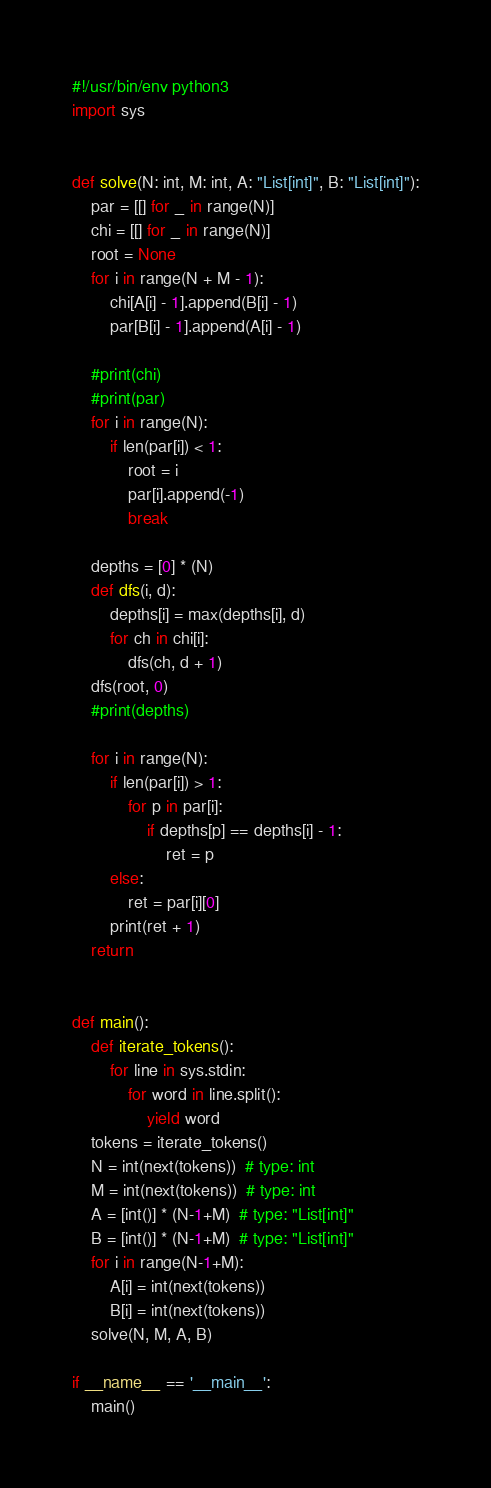<code> <loc_0><loc_0><loc_500><loc_500><_Python_>#!/usr/bin/env python3
import sys


def solve(N: int, M: int, A: "List[int]", B: "List[int]"):
    par = [[] for _ in range(N)]
    chi = [[] for _ in range(N)]
    root = None
    for i in range(N + M - 1):
        chi[A[i] - 1].append(B[i] - 1)
        par[B[i] - 1].append(A[i] - 1)

    #print(chi)
    #print(par)
    for i in range(N):
        if len(par[i]) < 1:
            root = i
            par[i].append(-1)
            break

    depths = [0] * (N)
    def dfs(i, d):
        depths[i] = max(depths[i], d)
        for ch in chi[i]:
            dfs(ch, d + 1)
    dfs(root, 0)
    #print(depths)

    for i in range(N):
        if len(par[i]) > 1:
            for p in par[i]:
                if depths[p] == depths[i] - 1:
                    ret = p
        else:
            ret = par[i][0]
        print(ret + 1)
    return


def main():
    def iterate_tokens():
        for line in sys.stdin:
            for word in line.split():
                yield word
    tokens = iterate_tokens()
    N = int(next(tokens))  # type: int
    M = int(next(tokens))  # type: int
    A = [int()] * (N-1+M)  # type: "List[int]" 
    B = [int()] * (N-1+M)  # type: "List[int]" 
    for i in range(N-1+M):
        A[i] = int(next(tokens))
        B[i] = int(next(tokens))
    solve(N, M, A, B)

if __name__ == '__main__':
    main()
</code> 